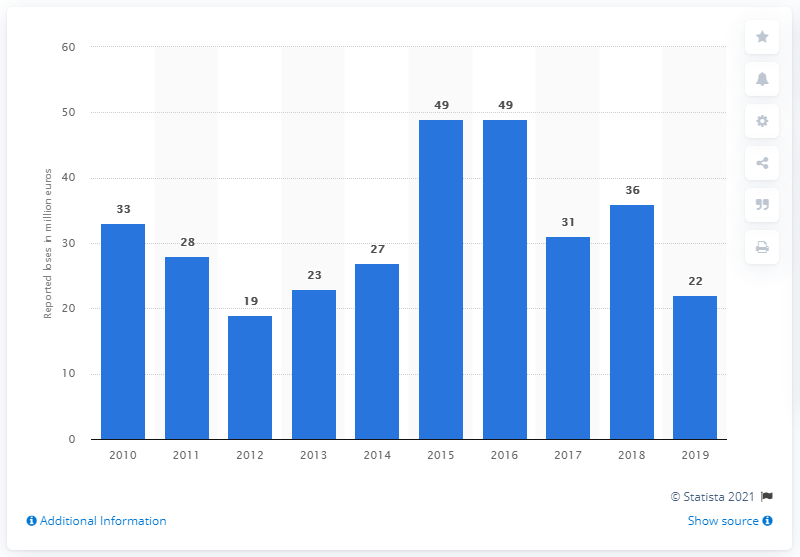Outline some significant characteristics in this image. The value of money lost as a result of ATM physical attacks in 2012 was approximately $19 million. The number of physical attacks in Europe began to increase in 2014. The amount of money lost as a result of ATM physical attacks in 2019 was approximately 22 million dollars. 